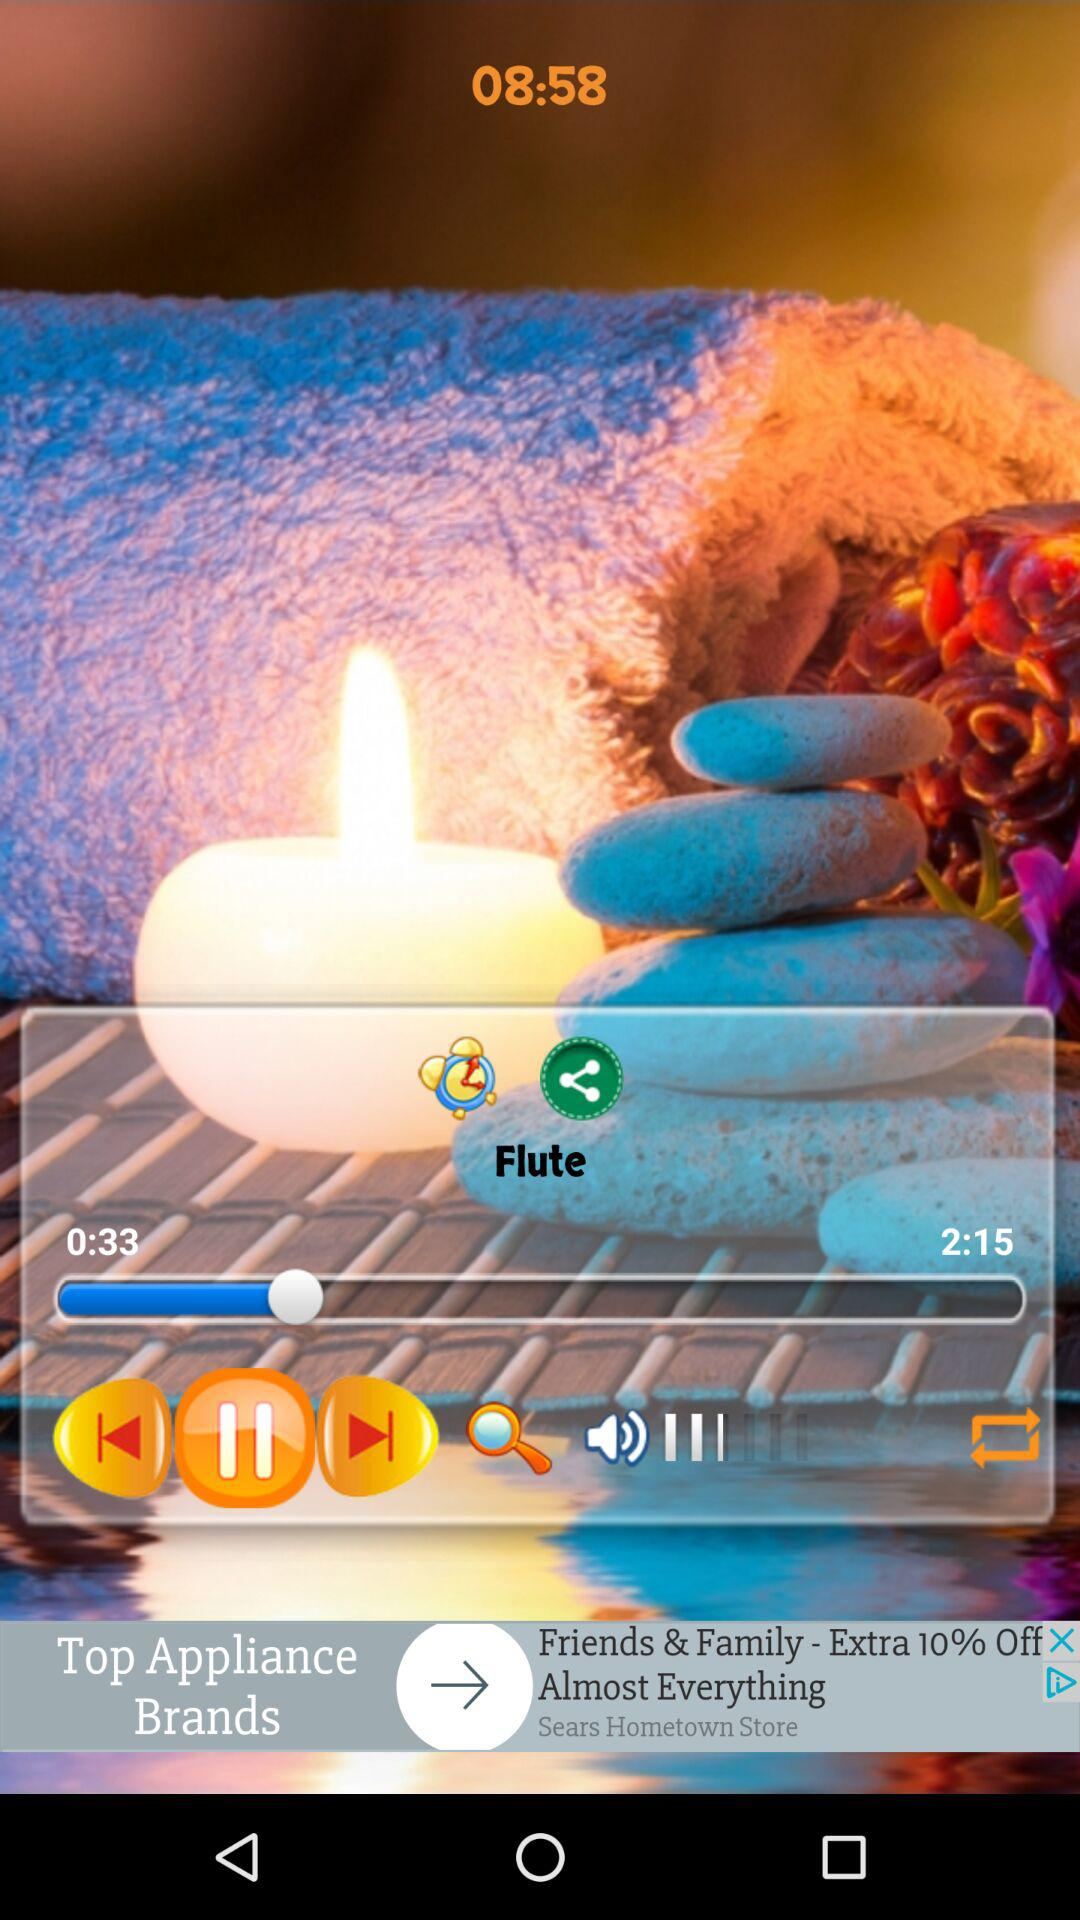What is the total duration? The total duration is 2 minutes 15 seconds. 